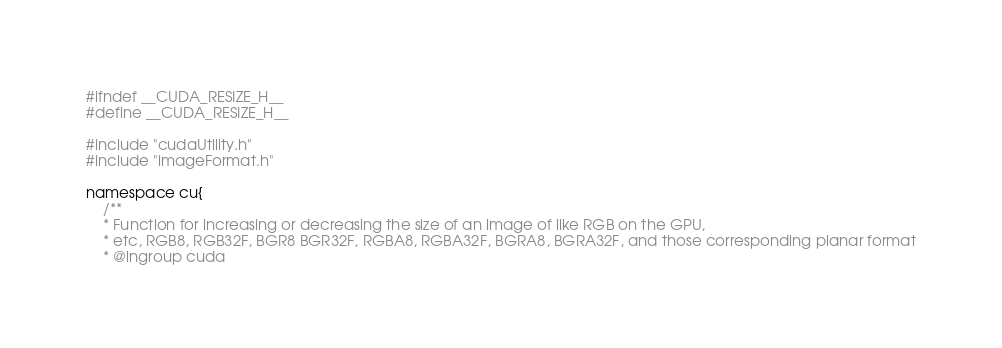<code> <loc_0><loc_0><loc_500><loc_500><_C_>#ifndef __CUDA_RESIZE_H__
#define __CUDA_RESIZE_H__

#include "cudaUtility.h"
#include "imageFormat.h"

namespace cu{
    /**
    * Function for increasing or decreasing the size of an image of like RGB on the GPU,
    * etc, RGB8, RGB32F, BGR8 BGR32F, RGBA8, RGBA32F, BGRA8, BGRA32F, and those corresponding planar format
    * @ingroup cuda</code> 